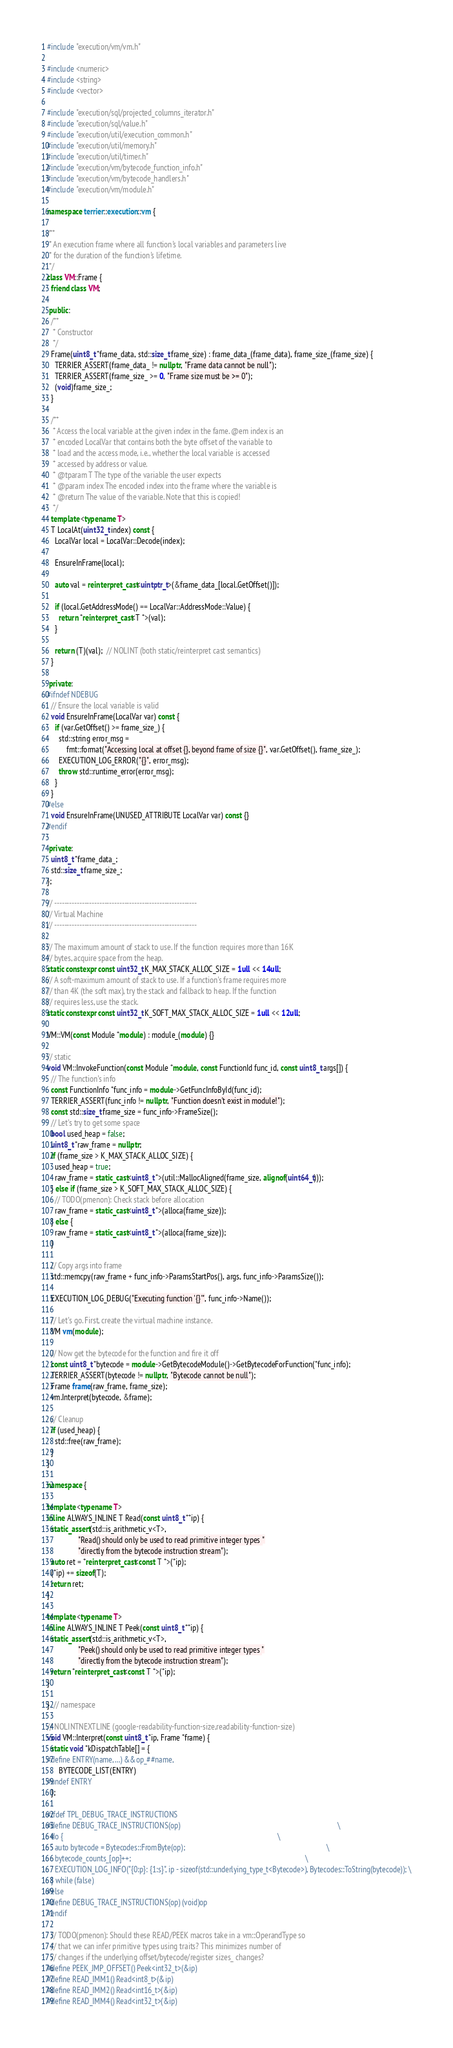Convert code to text. <code><loc_0><loc_0><loc_500><loc_500><_C++_>#include "execution/vm/vm.h"

#include <numeric>
#include <string>
#include <vector>

#include "execution/sql/projected_columns_iterator.h"
#include "execution/sql/value.h"
#include "execution/util/execution_common.h"
#include "execution/util/memory.h"
#include "execution/util/timer.h"
#include "execution/vm/bytecode_function_info.h"
#include "execution/vm/bytecode_handlers.h"
#include "execution/vm/module.h"

namespace terrier::execution::vm {

/**
 * An execution frame where all function's local variables and parameters live
 * for the duration of the function's lifetime.
 */
class VM::Frame {
  friend class VM;

 public:
  /**
   * Constructor
   */
  Frame(uint8_t *frame_data, std::size_t frame_size) : frame_data_(frame_data), frame_size_(frame_size) {
    TERRIER_ASSERT(frame_data_ != nullptr, "Frame data cannot be null");
    TERRIER_ASSERT(frame_size_ >= 0, "Frame size must be >= 0");
    (void)frame_size_;
  }

  /**
   * Access the local variable at the given index in the fame. @em index is an
   * encoded LocalVar that contains both the byte offset of the variable to
   * load and the access mode, i.e., whether the local variable is accessed
   * accessed by address or value.
   * @tparam T The type of the variable the user expects
   * @param index The encoded index into the frame where the variable is
   * @return The value of the variable. Note that this is copied!
   */
  template <typename T>
  T LocalAt(uint32_t index) const {
    LocalVar local = LocalVar::Decode(index);

    EnsureInFrame(local);

    auto val = reinterpret_cast<uintptr_t>(&frame_data_[local.GetOffset()]);

    if (local.GetAddressMode() == LocalVar::AddressMode::Value) {
      return *reinterpret_cast<T *>(val);
    }

    return (T)(val);  // NOLINT (both static/reinterpret cast semantics)
  }

 private:
#ifndef NDEBUG
  // Ensure the local variable is valid
  void EnsureInFrame(LocalVar var) const {
    if (var.GetOffset() >= frame_size_) {
      std::string error_msg =
          fmt::format("Accessing local at offset {}, beyond frame of size {}", var.GetOffset(), frame_size_);
      EXECUTION_LOG_ERROR("{}", error_msg);
      throw std::runtime_error(error_msg);
    }
  }
#else
  void EnsureInFrame(UNUSED_ATTRIBUTE LocalVar var) const {}
#endif

 private:
  uint8_t *frame_data_;
  std::size_t frame_size_;
};

// ---------------------------------------------------------
// Virtual Machine
// ---------------------------------------------------------

// The maximum amount of stack to use. If the function requires more than 16K
// bytes, acquire space from the heap.
static constexpr const uint32_t K_MAX_STACK_ALLOC_SIZE = 1ull << 14ull;
// A soft-maximum amount of stack to use. If a function's frame requires more
// than 4K (the soft max), try the stack and fallback to heap. If the function
// requires less, use the stack.
static constexpr const uint32_t K_SOFT_MAX_STACK_ALLOC_SIZE = 1ull << 12ull;

VM::VM(const Module *module) : module_(module) {}

// static
void VM::InvokeFunction(const Module *module, const FunctionId func_id, const uint8_t args[]) {
  // The function's info
  const FunctionInfo *func_info = module->GetFuncInfoById(func_id);
  TERRIER_ASSERT(func_info != nullptr, "Function doesn't exist in module!");
  const std::size_t frame_size = func_info->FrameSize();
  // Let's try to get some space
  bool used_heap = false;
  uint8_t *raw_frame = nullptr;
  if (frame_size > K_MAX_STACK_ALLOC_SIZE) {
    used_heap = true;
    raw_frame = static_cast<uint8_t *>(util::MallocAligned(frame_size, alignof(uint64_t)));
  } else if (frame_size > K_SOFT_MAX_STACK_ALLOC_SIZE) {
    // TODO(pmenon): Check stack before allocation
    raw_frame = static_cast<uint8_t *>(alloca(frame_size));
  } else {
    raw_frame = static_cast<uint8_t *>(alloca(frame_size));
  }

  // Copy args into frame
  std::memcpy(raw_frame + func_info->ParamsStartPos(), args, func_info->ParamsSize());

  EXECUTION_LOG_DEBUG("Executing function '{}'", func_info->Name());

  // Let's go. First, create the virtual machine instance.
  VM vm(module);

  // Now get the bytecode for the function and fire it off
  const uint8_t *bytecode = module->GetBytecodeModule()->GetBytecodeForFunction(*func_info);
  TERRIER_ASSERT(bytecode != nullptr, "Bytecode cannot be null");
  Frame frame(raw_frame, frame_size);
  vm.Interpret(bytecode, &frame);

  // Cleanup
  if (used_heap) {
    std::free(raw_frame);
  }
}

namespace {

template <typename T>
inline ALWAYS_INLINE T Read(const uint8_t **ip) {
  static_assert(std::is_arithmetic_v<T>,
                "Read() should only be used to read primitive integer types "
                "directly from the bytecode instruction stream");
  auto ret = *reinterpret_cast<const T *>(*ip);
  (*ip) += sizeof(T);
  return ret;
}

template <typename T>
inline ALWAYS_INLINE T Peek(const uint8_t **ip) {
  static_assert(std::is_arithmetic_v<T>,
                "Peek() should only be used to read primitive integer types "
                "directly from the bytecode instruction stream");
  return *reinterpret_cast<const T *>(*ip);
}

}  // namespace

// NOLINTNEXTLINE (google-readability-function-size,readability-function-size)
void VM::Interpret(const uint8_t *ip, Frame *frame) {
  static void *kDispatchTable[] = {
#define ENTRY(name, ...) &&op_##name,
      BYTECODE_LIST(ENTRY)
#undef ENTRY
  };

#ifdef TPL_DEBUG_TRACE_INSTRUCTIONS
#define DEBUG_TRACE_INSTRUCTIONS(op)                                                                                  \
  do {                                                                                                                \
    auto bytecode = Bytecodes::FromByte(op);                                                                          \
    bytecode_counts_[op]++;                                                                                           \
    EXECUTION_LOG_INFO("{0:p}: {1:s}", ip - sizeof(std::underlying_type_t<Bytecode>), Bytecodes::ToString(bytecode)); \
  } while (false)
#else
#define DEBUG_TRACE_INSTRUCTIONS(op) (void)op
#endif

  // TODO(pmenon): Should these READ/PEEK macros take in a vm::OperandType so
  // that we can infer primitive types using traits? This minimizes number of
  // changes if the underlying offset/bytecode/register sizes_ changes?
#define PEEK_JMP_OFFSET() Peek<int32_t>(&ip)
#define READ_IMM1() Read<int8_t>(&ip)
#define READ_IMM2() Read<int16_t>(&ip)
#define READ_IMM4() Read<int32_t>(&ip)</code> 